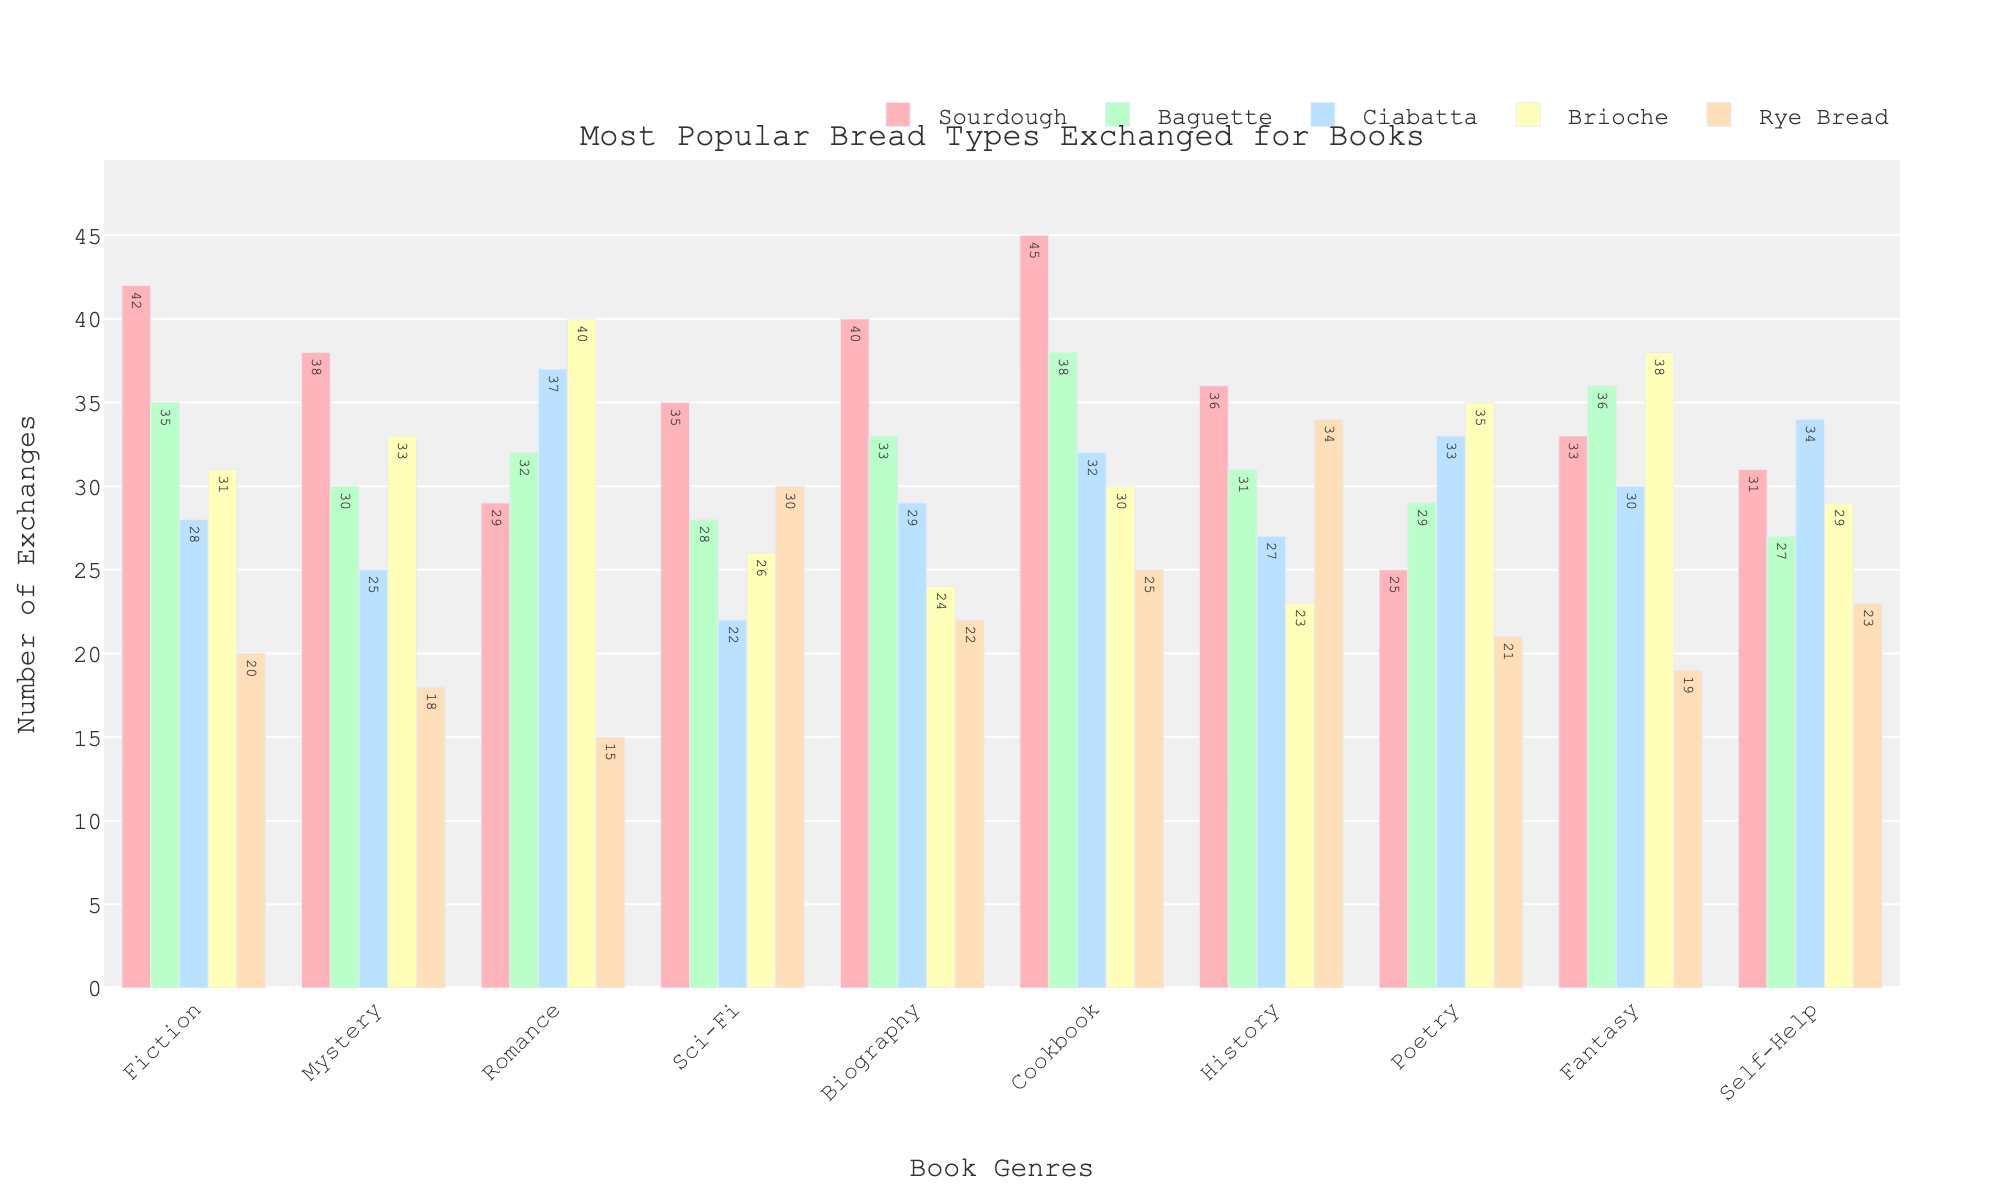Which genre has the highest number of sourdough exchanges? To find the genre with the highest number of sourdough exchanges, look for the tallest bar in the Sourdough section, which is colored red. The genre with the highest value is Cookbook.
Answer: Cookbook Which bread type is the most popular in the Romance genre? To find the most popular bread type in the Romance genre, compare the heights of the bars in the Romance section. The tallest bar is for Brioche.
Answer: Brioche What is the total number of Ciabatta exchanges across all genres? To find the total number of Ciabatta exchanges, add up the values for Ciabatta in each genre. The sum is 28 + 25 + 37 + 22 + 29 + 32 + 27 + 33 + 30 + 34 = 297.
Answer: 297 Which genre has the lowest number of Rye Bread exchanges? To find the genre with the lowest number of Rye Bread exchanges, look for the shortest bar in the Rye Bread section, which is colored brown. The genre with the lowest value is Romance.
Answer: Romance Compare the number of Brioche exchanges between Fantasy and Poetry genres. Which has more exchanges and by how much? To compare the number of Brioche exchanges between Fantasy and Poetry, find the bar heights for Brioche in both genres. Fantasy has 38 and Poetry has 35. The difference is 38 - 35, so Fantasy has 3 more exchanges.
Answer: Fantasy, 3 What is the average number of Baguette exchanges across all genres? To find the average number of Baguette exchanges, sum the values for Baguette in each genre and divide by the number of genres. The sum is 35 + 30 + 32 + 28 + 33 + 38 + 31 + 29 + 36 + 27 = 319. Dividing by 10 genres, the average is 319/10 = 31.9.
Answer: 31.9 Which bread type has the highest overall total exchanges across all genres? To find the bread type with the highest overall total exchanges, sum the exchanges for each bread type across all genres and compare the totals. Sourdough: 42+38+29+35+40+45+36+25+33+31=354; Baguette: 35+30+32+28+33+38+31+29+36+27=319; Ciabatta: 28+25+37+22+29+32+27+33+30+34=297; Brioche: 31+33+40+26+24+30+23+35+38+29=309; Rye Bread: 20+18+15+30+22+25+34+21+19+23=227. Sourdough has the highest total.
Answer: Sourdough How much more popular is Sourdough compared to Rye Bread in the Mystery genre? To determine how much more popular Sourdough is compared to Rye Bread in the Mystery genre, subtract the number of Rye Bread exchanges from the number of Sourdough exchanges in that genre. Sourdough has 38 exchanges and Rye Bread has 18; hence the difference is 38 - 18 = 20.
Answer: 20 more Which genre has the highest number of exchanges for Baguette? To find the genre with the highest number of Baguette exchanges, look for the tallest bar in the Baguette section, which is colored green. The genre with the highest value is Cookbook.
Answer: Cookbook Is the number of exchanges for Ciabatta in the Fiction genre higher or lower than in the Biography genre? By how much? To compare the number of Ciabatta exchanges in Fiction and Biography, find the values for Ciabatta in both genres. Fiction has 28 and Biography has 29. The difference is 29 - 28, so Biography has 1 more exchange.
Answer: Biography, 1 more 